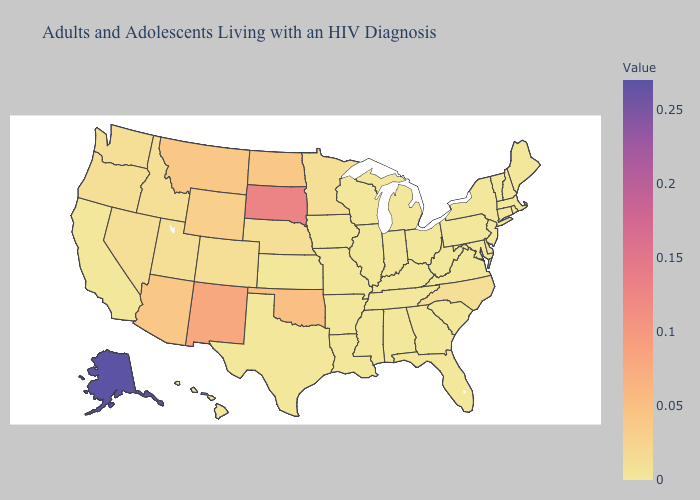Does New Mexico have the highest value in the USA?
Be succinct. No. Does Alaska have the highest value in the USA?
Quick response, please. Yes. Which states have the lowest value in the USA?
Keep it brief. Alabama, Arkansas, California, Connecticut, Delaware, Florida, Georgia, Hawaii, Illinois, Indiana, Iowa, Kansas, Kentucky, Louisiana, Maine, Maryland, Massachusetts, Michigan, Mississippi, Missouri, New Hampshire, New Jersey, New York, Ohio, Pennsylvania, Rhode Island, South Carolina, Tennessee, Texas, Vermont, Virginia, West Virginia, Wisconsin. Which states hav the highest value in the Northeast?
Concise answer only. Connecticut, Maine, Massachusetts, New Hampshire, New Jersey, New York, Pennsylvania, Rhode Island, Vermont. Does Alaska have the highest value in the West?
Write a very short answer. Yes. Does Alaska have the highest value in the USA?
Keep it brief. Yes. Does the map have missing data?
Keep it brief. No. Does Arkansas have a higher value than Arizona?
Short answer required. No. 